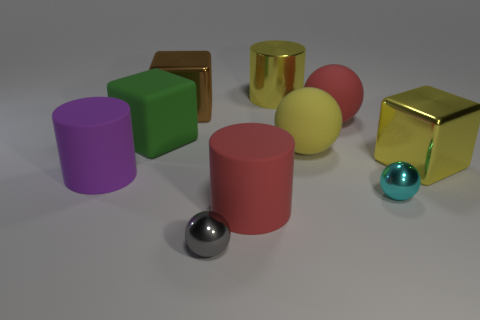Subtract all balls. How many objects are left? 6 Subtract 0 cyan cylinders. How many objects are left? 10 Subtract all red matte blocks. Subtract all cyan metal balls. How many objects are left? 9 Add 6 tiny cyan balls. How many tiny cyan balls are left? 7 Add 5 large blue rubber objects. How many large blue rubber objects exist? 5 